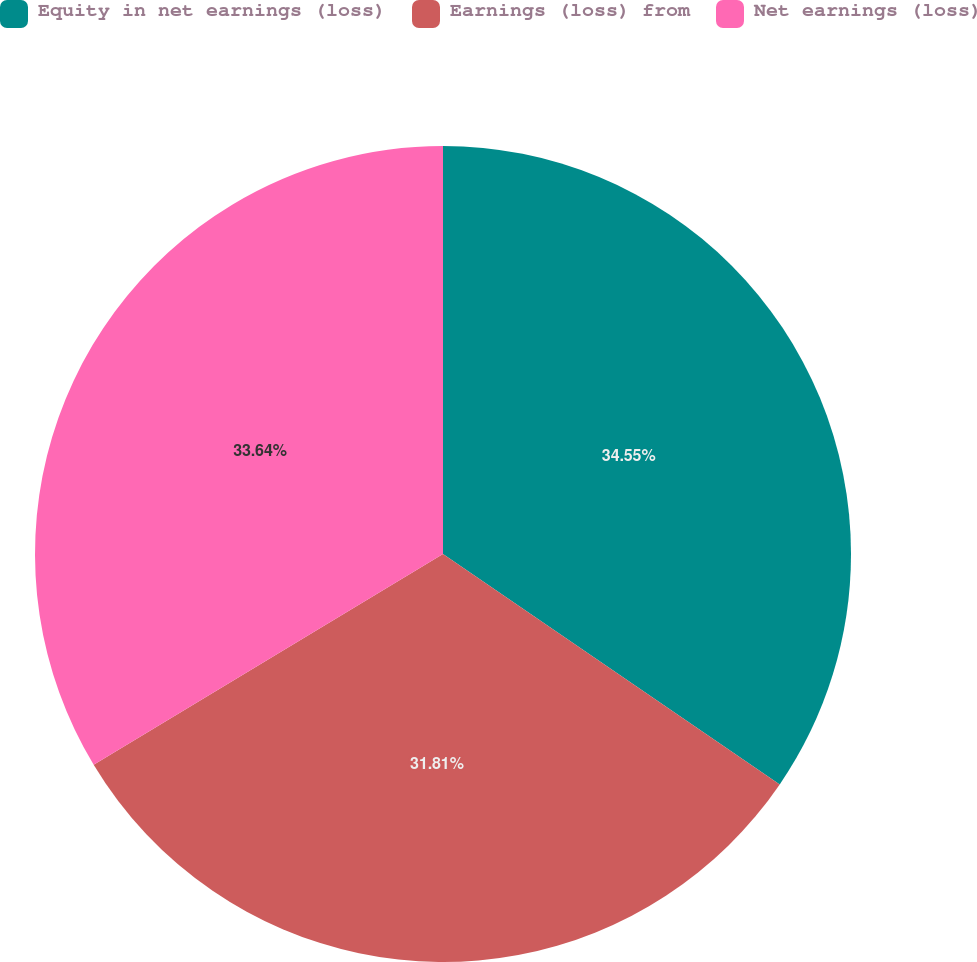Convert chart. <chart><loc_0><loc_0><loc_500><loc_500><pie_chart><fcel>Equity in net earnings (loss)<fcel>Earnings (loss) from<fcel>Net earnings (loss)<nl><fcel>34.55%<fcel>31.81%<fcel>33.64%<nl></chart> 